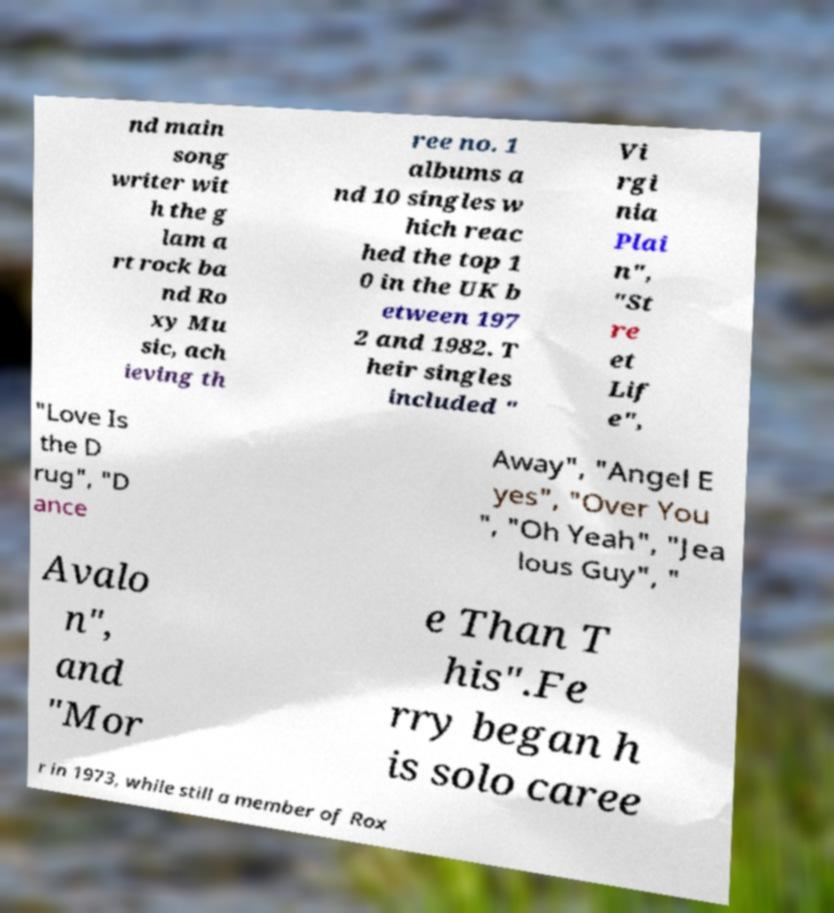Please read and relay the text visible in this image. What does it say? nd main song writer wit h the g lam a rt rock ba nd Ro xy Mu sic, ach ieving th ree no. 1 albums a nd 10 singles w hich reac hed the top 1 0 in the UK b etween 197 2 and 1982. T heir singles included " Vi rgi nia Plai n", "St re et Lif e", "Love Is the D rug", "D ance Away", "Angel E yes", "Over You ", "Oh Yeah", "Jea lous Guy", " Avalo n", and "Mor e Than T his".Fe rry began h is solo caree r in 1973, while still a member of Rox 